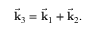Convert formula to latex. <formula><loc_0><loc_0><loc_500><loc_500>{ \vec { k } } _ { 3 } = { \vec { k } } _ { 1 } + { \vec { k } } _ { 2 } .</formula> 